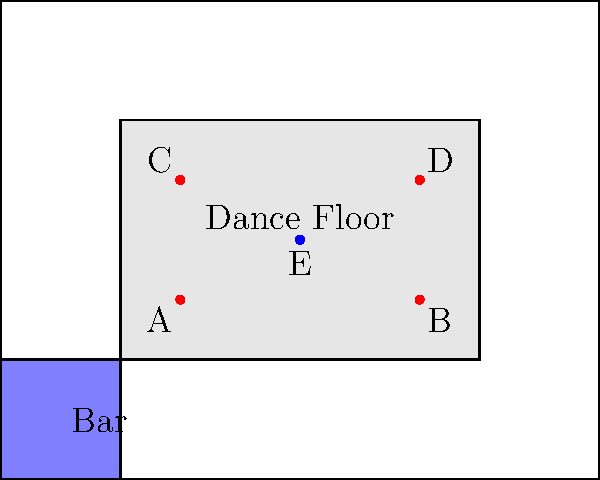In the diagram above, which lighting fixture placement would be most effective for creating a captivating centerpiece effect for a neon body painting event? To determine the most effective lighting fixture placement for a neon body painting event, we need to consider the following factors:

1. Central location: The ideal placement should be at the center of the dance floor to create a focal point.

2. Coverage: The light should reach as much of the dance floor as possible to illuminate the neon body paint on the attendees.

3. Uniqueness: A single, centralized light source can create a more dramatic effect than multiple scattered lights.

4. Intensity: A central light can be more powerful, enhancing the glow of the neon paints.

Analyzing the diagram:

- Fixtures A, B, C, and D are placed at the corners of the dance floor. While they provide good coverage, they don't create a centralized effect.
- Fixture E is located at the center of the dance floor.

Given these considerations:

1. Fixture E is ideally positioned at the center of the dance floor.
2. Its central location allows for even coverage of the entire dance area.
3. As a single, centralized source, it can create a more dramatic and focused lighting effect.
4. The central placement allows for a higher-intensity light that can make the neon body paint glow more vibrantly.

Therefore, fixture E would be the most effective for creating a captivating centerpiece effect for a neon body painting event.
Answer: E 